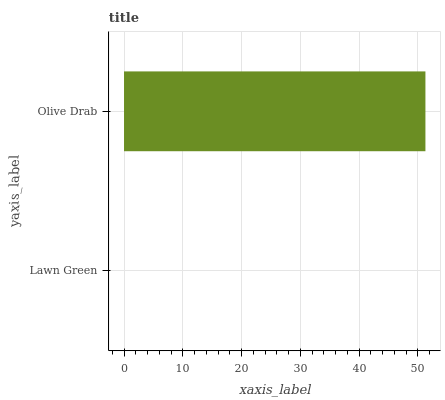Is Lawn Green the minimum?
Answer yes or no. Yes. Is Olive Drab the maximum?
Answer yes or no. Yes. Is Olive Drab the minimum?
Answer yes or no. No. Is Olive Drab greater than Lawn Green?
Answer yes or no. Yes. Is Lawn Green less than Olive Drab?
Answer yes or no. Yes. Is Lawn Green greater than Olive Drab?
Answer yes or no. No. Is Olive Drab less than Lawn Green?
Answer yes or no. No. Is Olive Drab the high median?
Answer yes or no. Yes. Is Lawn Green the low median?
Answer yes or no. Yes. Is Lawn Green the high median?
Answer yes or no. No. Is Olive Drab the low median?
Answer yes or no. No. 